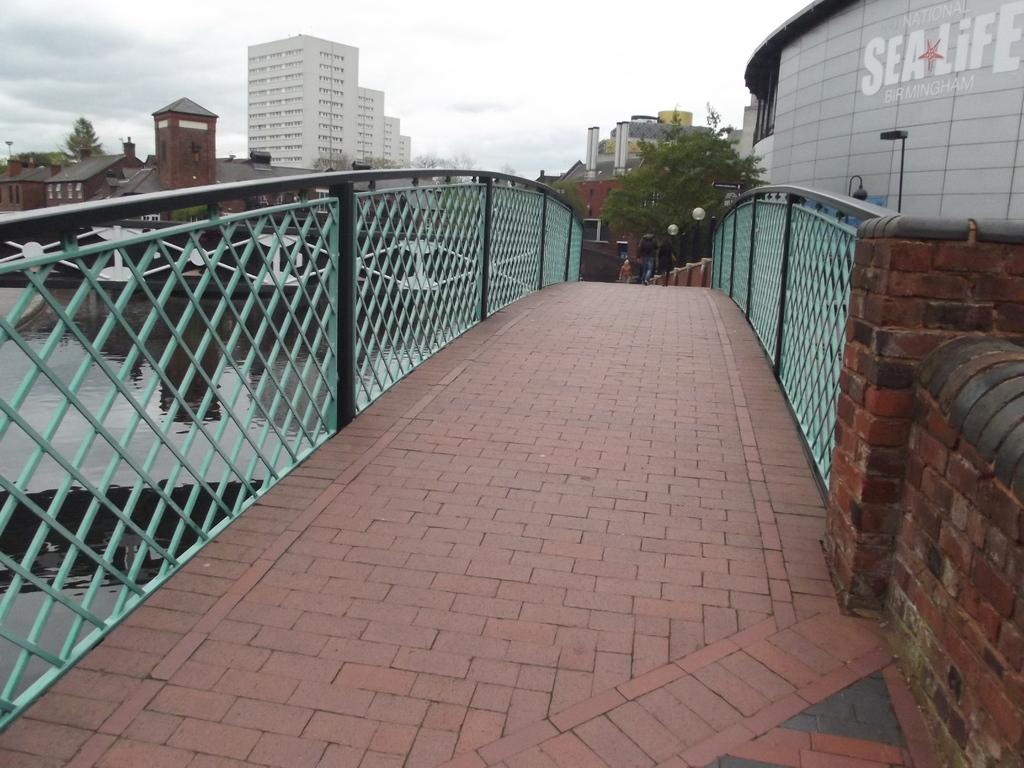What structure can be seen in the image that connects two areas? There is a bridge in the image that connects two areas. What is the bridge positioned over? The bridge is over a lake. What type of lighting is present in the image? There are light poles in the image. What type of structures can be seen in the background? There are buildings in the image. What type of vegetation is present in the image? There are trees in the image. What is visible at the top of the image? The sky is visible at the top of the image. What type of account is being discussed in the image? There is no account being discussed in the image; it features a bridge over a lake with light poles, buildings, trees, and a visible sky. What button is being pressed in the image? There is no button being pressed in the image; it features a bridge over a lake with light poles, buildings, trees, and a visible sky. 